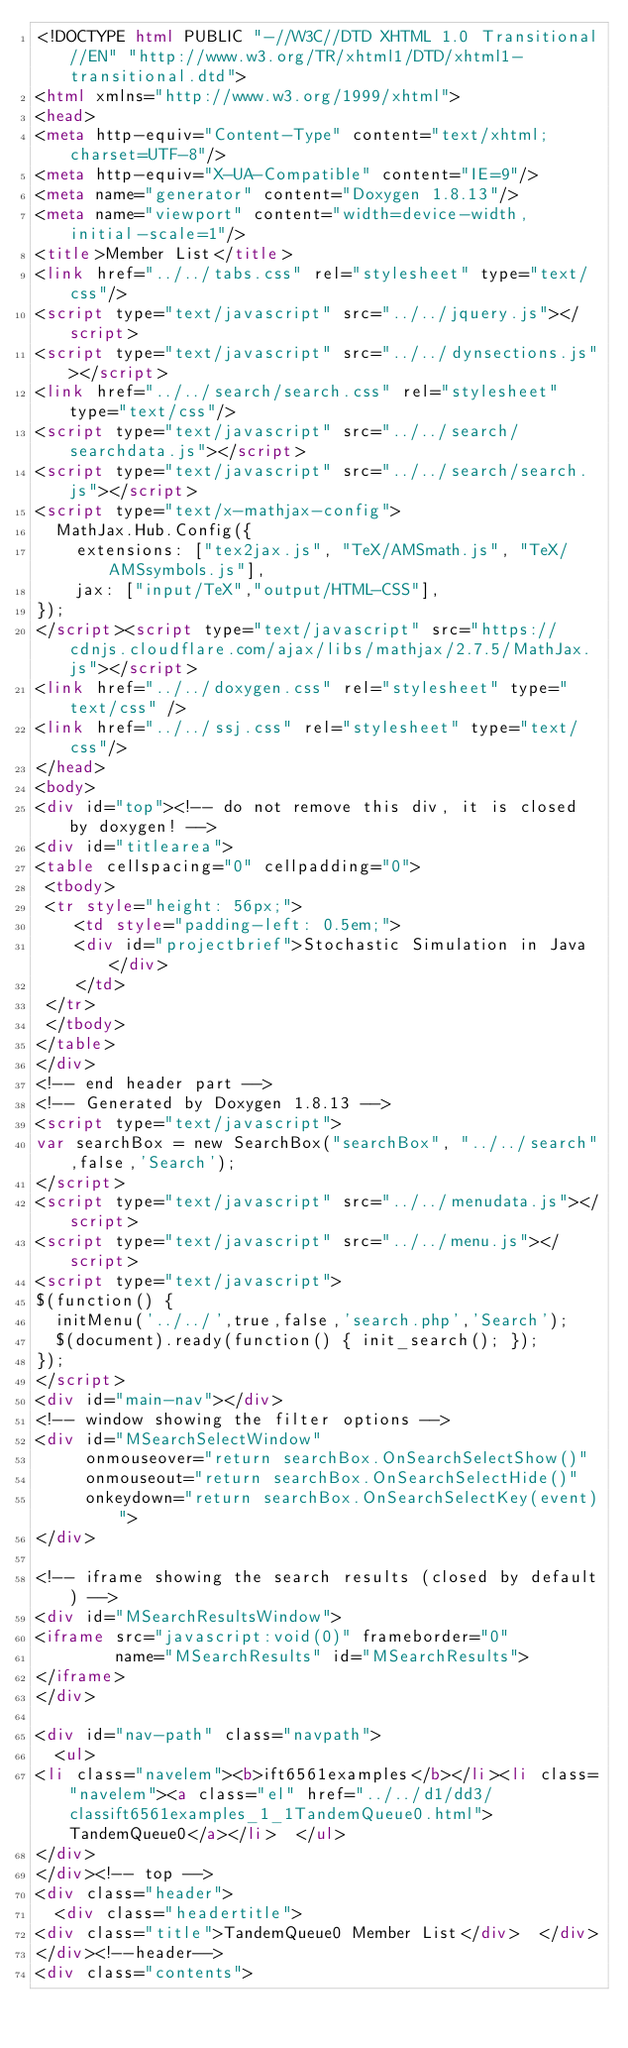<code> <loc_0><loc_0><loc_500><loc_500><_HTML_><!DOCTYPE html PUBLIC "-//W3C//DTD XHTML 1.0 Transitional//EN" "http://www.w3.org/TR/xhtml1/DTD/xhtml1-transitional.dtd">
<html xmlns="http://www.w3.org/1999/xhtml">
<head>
<meta http-equiv="Content-Type" content="text/xhtml;charset=UTF-8"/>
<meta http-equiv="X-UA-Compatible" content="IE=9"/>
<meta name="generator" content="Doxygen 1.8.13"/>
<meta name="viewport" content="width=device-width, initial-scale=1"/>
<title>Member List</title>
<link href="../../tabs.css" rel="stylesheet" type="text/css"/>
<script type="text/javascript" src="../../jquery.js"></script>
<script type="text/javascript" src="../../dynsections.js"></script>
<link href="../../search/search.css" rel="stylesheet" type="text/css"/>
<script type="text/javascript" src="../../search/searchdata.js"></script>
<script type="text/javascript" src="../../search/search.js"></script>
<script type="text/x-mathjax-config">
  MathJax.Hub.Config({
    extensions: ["tex2jax.js", "TeX/AMSmath.js", "TeX/AMSsymbols.js"],
    jax: ["input/TeX","output/HTML-CSS"],
});
</script><script type="text/javascript" src="https://cdnjs.cloudflare.com/ajax/libs/mathjax/2.7.5/MathJax.js"></script>
<link href="../../doxygen.css" rel="stylesheet" type="text/css" />
<link href="../../ssj.css" rel="stylesheet" type="text/css"/>
</head>
<body>
<div id="top"><!-- do not remove this div, it is closed by doxygen! -->
<div id="titlearea">
<table cellspacing="0" cellpadding="0">
 <tbody>
 <tr style="height: 56px;">
    <td style="padding-left: 0.5em;">
    <div id="projectbrief">Stochastic Simulation in Java</div>
    </td>
 </tr>
 </tbody>
</table>
</div>
<!-- end header part -->
<!-- Generated by Doxygen 1.8.13 -->
<script type="text/javascript">
var searchBox = new SearchBox("searchBox", "../../search",false,'Search');
</script>
<script type="text/javascript" src="../../menudata.js"></script>
<script type="text/javascript" src="../../menu.js"></script>
<script type="text/javascript">
$(function() {
  initMenu('../../',true,false,'search.php','Search');
  $(document).ready(function() { init_search(); });
});
</script>
<div id="main-nav"></div>
<!-- window showing the filter options -->
<div id="MSearchSelectWindow"
     onmouseover="return searchBox.OnSearchSelectShow()"
     onmouseout="return searchBox.OnSearchSelectHide()"
     onkeydown="return searchBox.OnSearchSelectKey(event)">
</div>

<!-- iframe showing the search results (closed by default) -->
<div id="MSearchResultsWindow">
<iframe src="javascript:void(0)" frameborder="0" 
        name="MSearchResults" id="MSearchResults">
</iframe>
</div>

<div id="nav-path" class="navpath">
  <ul>
<li class="navelem"><b>ift6561examples</b></li><li class="navelem"><a class="el" href="../../d1/dd3/classift6561examples_1_1TandemQueue0.html">TandemQueue0</a></li>  </ul>
</div>
</div><!-- top -->
<div class="header">
  <div class="headertitle">
<div class="title">TandemQueue0 Member List</div>  </div>
</div><!--header-->
<div class="contents">
</code> 